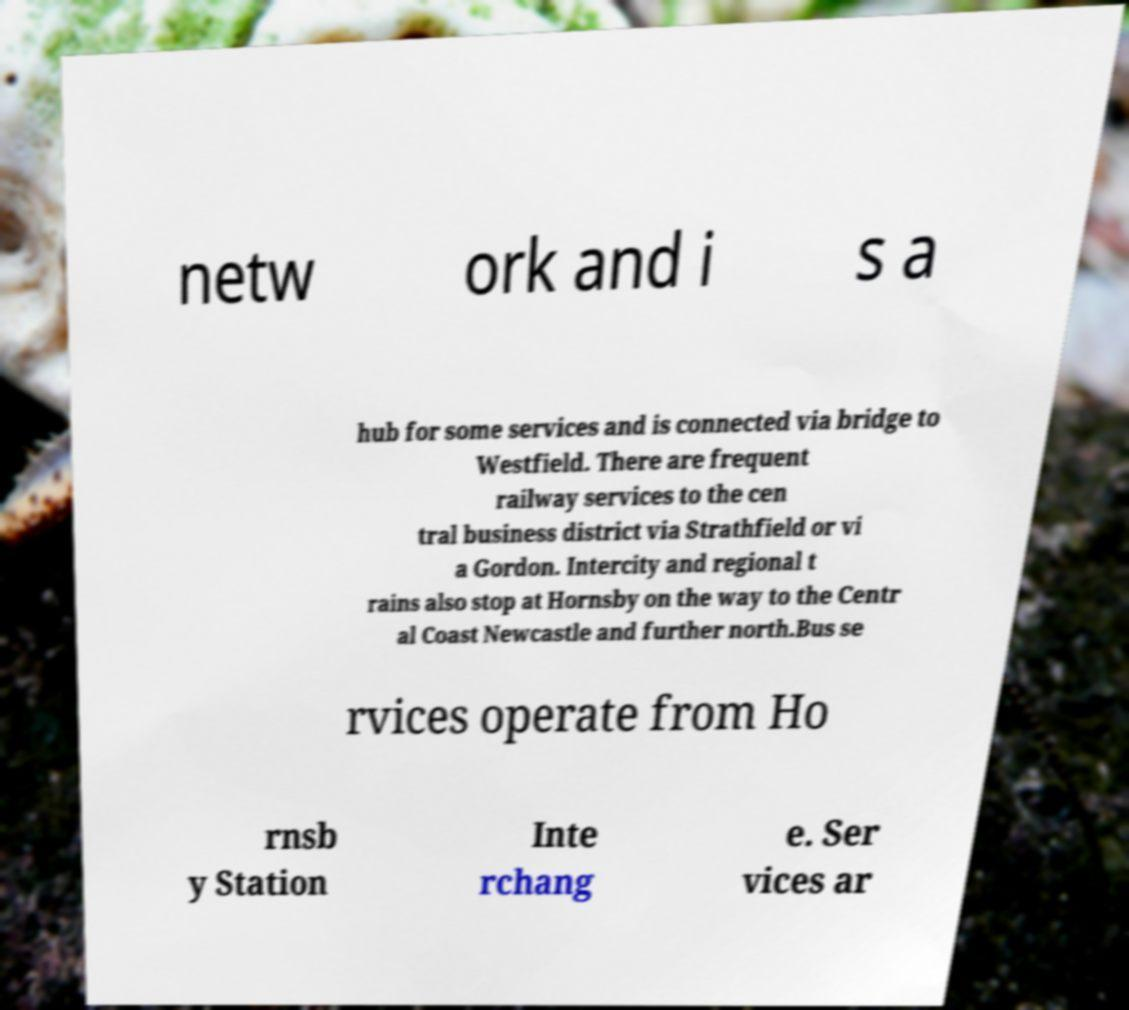Can you accurately transcribe the text from the provided image for me? netw ork and i s a hub for some services and is connected via bridge to Westfield. There are frequent railway services to the cen tral business district via Strathfield or vi a Gordon. Intercity and regional t rains also stop at Hornsby on the way to the Centr al Coast Newcastle and further north.Bus se rvices operate from Ho rnsb y Station Inte rchang e. Ser vices ar 